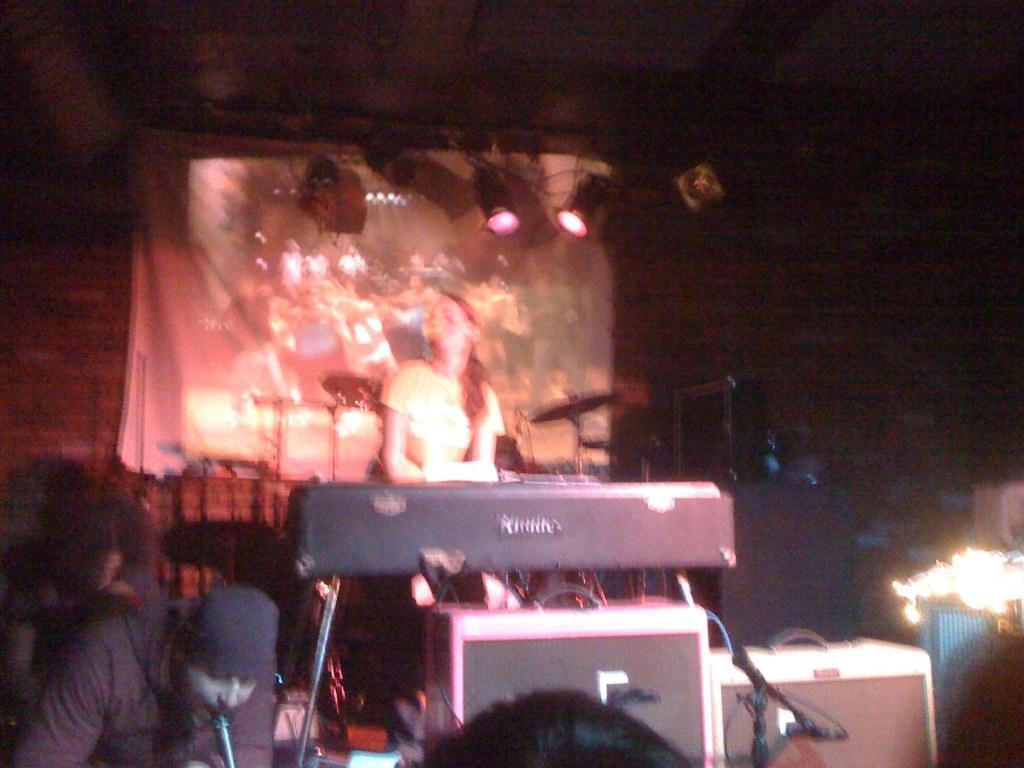Describe this image in one or two sentences. In this image, in the middle, we can see a woman is in front of a keyboard. On the left side, we can see a man playing a musical instrument. In the background, we can see some speakers, electronic instrument, musical instrument, electric wires, screen. At the top, we can see a roof with few lights, at the bottom, we can see hair of a person. 